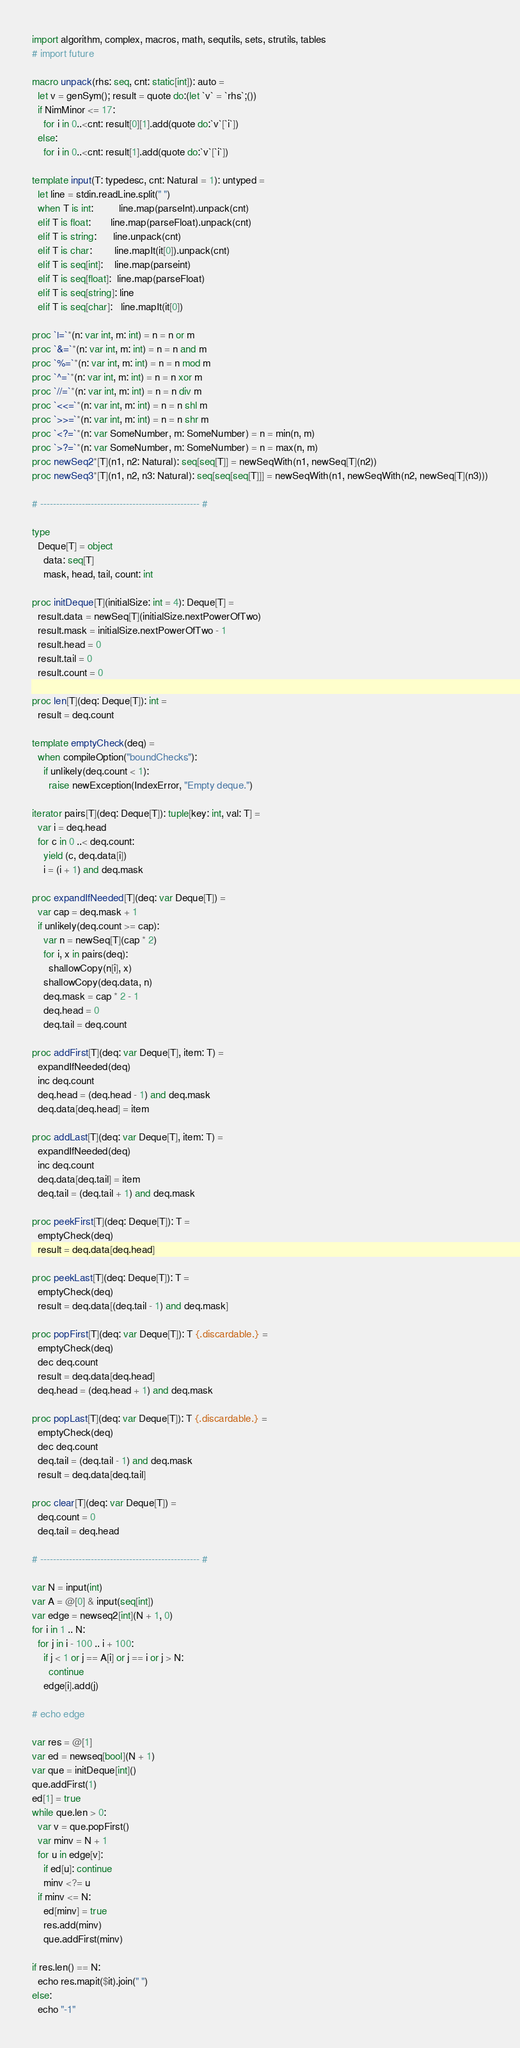<code> <loc_0><loc_0><loc_500><loc_500><_Nim_>import algorithm, complex, macros, math, sequtils, sets, strutils, tables
# import future

macro unpack(rhs: seq, cnt: static[int]): auto =
  let v = genSym(); result = quote do:(let `v` = `rhs`;())
  if NimMinor <= 17:
    for i in 0..<cnt: result[0][1].add(quote do:`v`[`i`])
  else:
    for i in 0..<cnt: result[1].add(quote do:`v`[`i`])

template input(T: typedesc, cnt: Natural = 1): untyped =
  let line = stdin.readLine.split(" ")
  when T is int:         line.map(parseInt).unpack(cnt)
  elif T is float:       line.map(parseFloat).unpack(cnt)
  elif T is string:      line.unpack(cnt)
  elif T is char:        line.mapIt(it[0]).unpack(cnt)
  elif T is seq[int]:    line.map(parseint)
  elif T is seq[float]:  line.map(parseFloat)
  elif T is seq[string]: line
  elif T is seq[char]:   line.mapIt(it[0])

proc `|=`*(n: var int, m: int) = n = n or m
proc `&=`*(n: var int, m: int) = n = n and m
proc `%=`*(n: var int, m: int) = n = n mod m
proc `^=`*(n: var int, m: int) = n = n xor m
proc `//=`*(n: var int, m: int) = n = n div m
proc `<<=`*(n: var int, m: int) = n = n shl m
proc `>>=`*(n: var int, m: int) = n = n shr m
proc `<?=`*(n: var SomeNumber, m: SomeNumber) = n = min(n, m)
proc `>?=`*(n: var SomeNumber, m: SomeNumber) = n = max(n, m)
proc newSeq2*[T](n1, n2: Natural): seq[seq[T]] = newSeqWith(n1, newSeq[T](n2))
proc newSeq3*[T](n1, n2, n3: Natural): seq[seq[seq[T]]] = newSeqWith(n1, newSeqWith(n2, newSeq[T](n3)))

# -------------------------------------------------- #

type
  Deque[T] = object
    data: seq[T]
    mask, head, tail, count: int

proc initDeque[T](initialSize: int = 4): Deque[T] =
  result.data = newSeq[T](initialSize.nextPowerOfTwo)
  result.mask = initialSize.nextPowerOfTwo - 1
  result.head = 0
  result.tail = 0
  result.count = 0
  
proc len[T](deq: Deque[T]): int =
  result = deq.count

template emptyCheck(deq) =
  when compileOption("boundChecks"):
    if unlikely(deq.count < 1):
      raise newException(IndexError, "Empty deque.")

iterator pairs[T](deq: Deque[T]): tuple[key: int, val: T] =
  var i = deq.head
  for c in 0 ..< deq.count:
    yield (c, deq.data[i])
    i = (i + 1) and deq.mask

proc expandIfNeeded[T](deq: var Deque[T]) =
  var cap = deq.mask + 1
  if unlikely(deq.count >= cap):
    var n = newSeq[T](cap * 2)
    for i, x in pairs(deq):
      shallowCopy(n[i], x)
    shallowCopy(deq.data, n)
    deq.mask = cap * 2 - 1
    deq.head = 0
    deq.tail = deq.count

proc addFirst[T](deq: var Deque[T], item: T) =
  expandIfNeeded(deq)
  inc deq.count
  deq.head = (deq.head - 1) and deq.mask
  deq.data[deq.head] = item

proc addLast[T](deq: var Deque[T], item: T) =
  expandIfNeeded(deq)
  inc deq.count
  deq.data[deq.tail] = item
  deq.tail = (deq.tail + 1) and deq.mask

proc peekFirst[T](deq: Deque[T]): T =
  emptyCheck(deq)
  result = deq.data[deq.head]

proc peekLast[T](deq: Deque[T]): T =
  emptyCheck(deq)
  result = deq.data[(deq.tail - 1) and deq.mask]

proc popFirst[T](deq: var Deque[T]): T {.discardable.} =
  emptyCheck(deq)
  dec deq.count
  result = deq.data[deq.head]
  deq.head = (deq.head + 1) and deq.mask

proc popLast[T](deq: var Deque[T]): T {.discardable.} =
  emptyCheck(deq)
  dec deq.count
  deq.tail = (deq.tail - 1) and deq.mask
  result = deq.data[deq.tail]

proc clear[T](deq: var Deque[T]) =
  deq.count = 0
  deq.tail = deq.head

# -------------------------------------------------- #

var N = input(int)
var A = @[0] & input(seq[int])
var edge = newseq2[int](N + 1, 0)
for i in 1 .. N:
  for j in i - 100 .. i + 100:
    if j < 1 or j == A[i] or j == i or j > N:
      continue
    edge[i].add(j)

# echo edge

var res = @[1]
var ed = newseq[bool](N + 1)
var que = initDeque[int]()
que.addFirst(1)
ed[1] = true
while que.len > 0:
  var v = que.popFirst()
  var minv = N + 1
  for u in edge[v]:
    if ed[u]: continue
    minv <?= u
  if minv <= N:
    ed[minv] = true
    res.add(minv)
    que.addFirst(minv)

if res.len() == N:
  echo res.mapit($it).join(" ")
else:
  echo "-1"</code> 